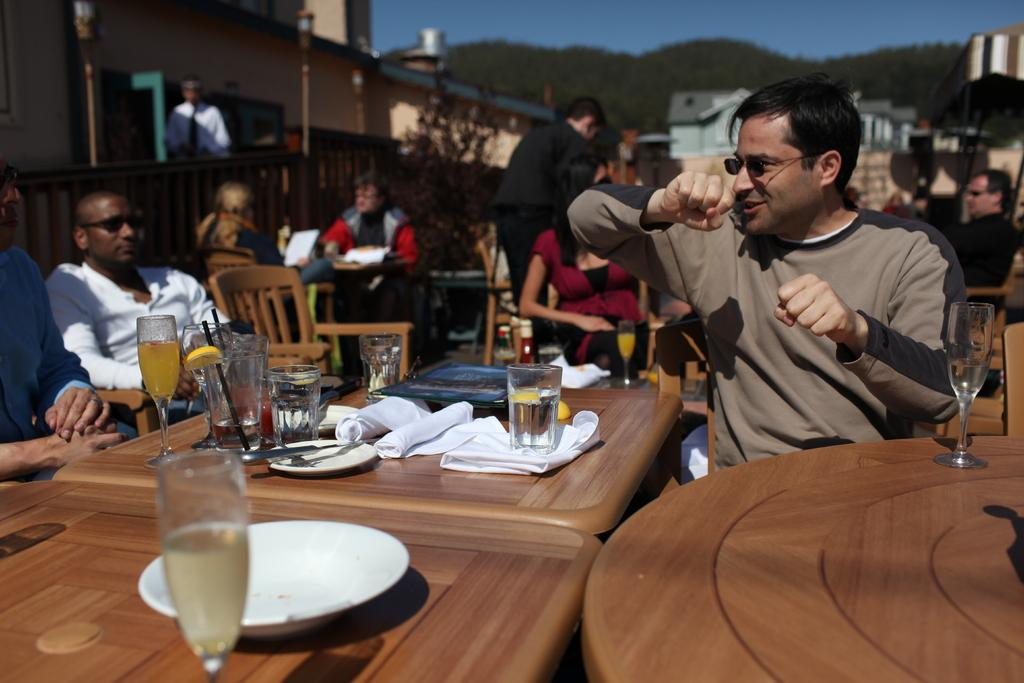What is the person in the image doing? The person is riding a bicycle. What can be seen in the foreground of the image? There is a road in the foreground. What type of knowledge is the person riding the bicycle sharing with the wax figure in the image? There is no wax figure present in the image, and the person riding the bicycle is not sharing any knowledge. 